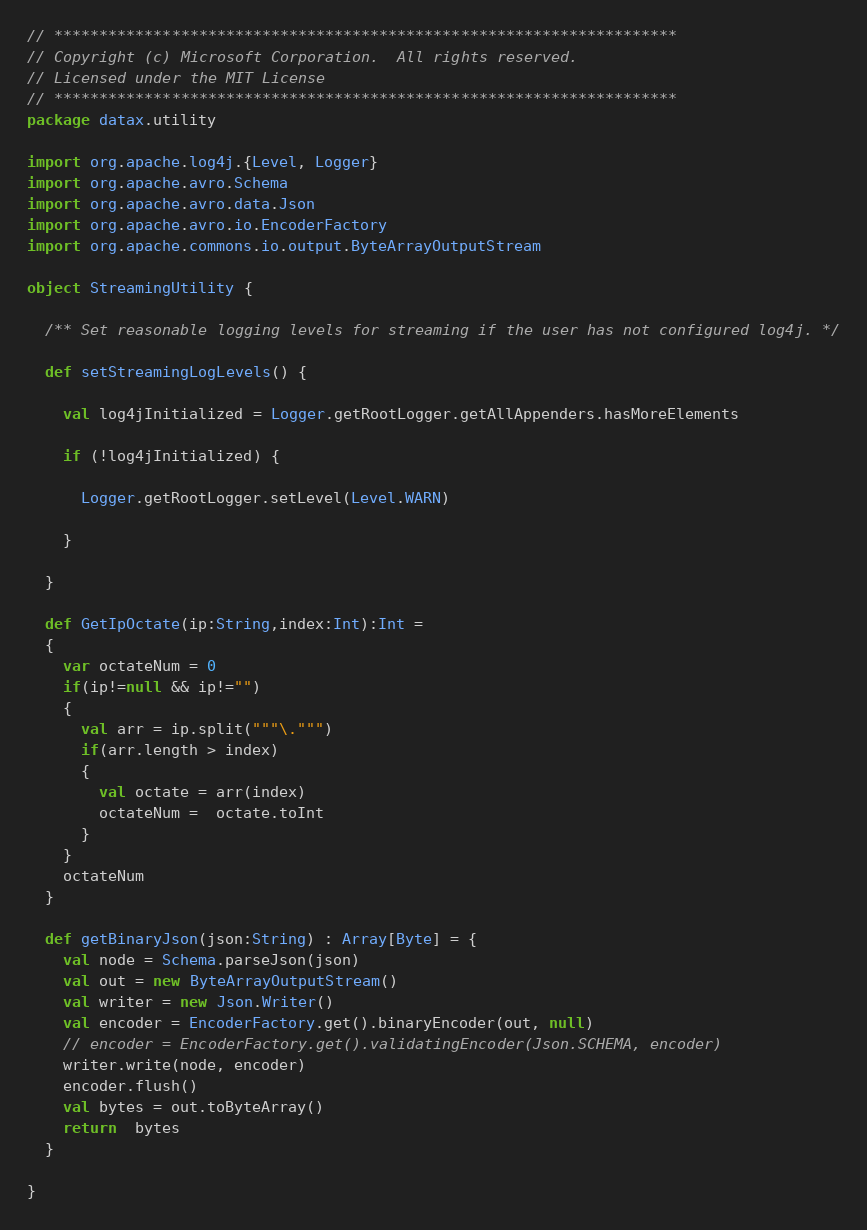Convert code to text. <code><loc_0><loc_0><loc_500><loc_500><_Scala_>// *********************************************************************
// Copyright (c) Microsoft Corporation.  All rights reserved.
// Licensed under the MIT License
// *********************************************************************
package datax.utility

import org.apache.log4j.{Level, Logger}
import org.apache.avro.Schema
import org.apache.avro.data.Json
import org.apache.avro.io.EncoderFactory
import org.apache.commons.io.output.ByteArrayOutputStream

object StreamingUtility {

  /** Set reasonable logging levels for streaming if the user has not configured log4j. */

  def setStreamingLogLevels() {

    val log4jInitialized = Logger.getRootLogger.getAllAppenders.hasMoreElements

    if (!log4jInitialized) {

      Logger.getRootLogger.setLevel(Level.WARN)

    }

  }

  def GetIpOctate(ip:String,index:Int):Int =
  {
    var octateNum = 0
    if(ip!=null && ip!="")
    {
      val arr = ip.split("""\.""")
      if(arr.length > index)
      {
        val octate = arr(index)
        octateNum =  octate.toInt
      }
    }
    octateNum
  }

  def getBinaryJson(json:String) : Array[Byte] = {
    val node = Schema.parseJson(json)
    val out = new ByteArrayOutputStream()
    val writer = new Json.Writer()
    val encoder = EncoderFactory.get().binaryEncoder(out, null)
    // encoder = EncoderFactory.get().validatingEncoder(Json.SCHEMA, encoder)
    writer.write(node, encoder)
    encoder.flush()
    val bytes = out.toByteArray()
    return  bytes
  }

}
</code> 